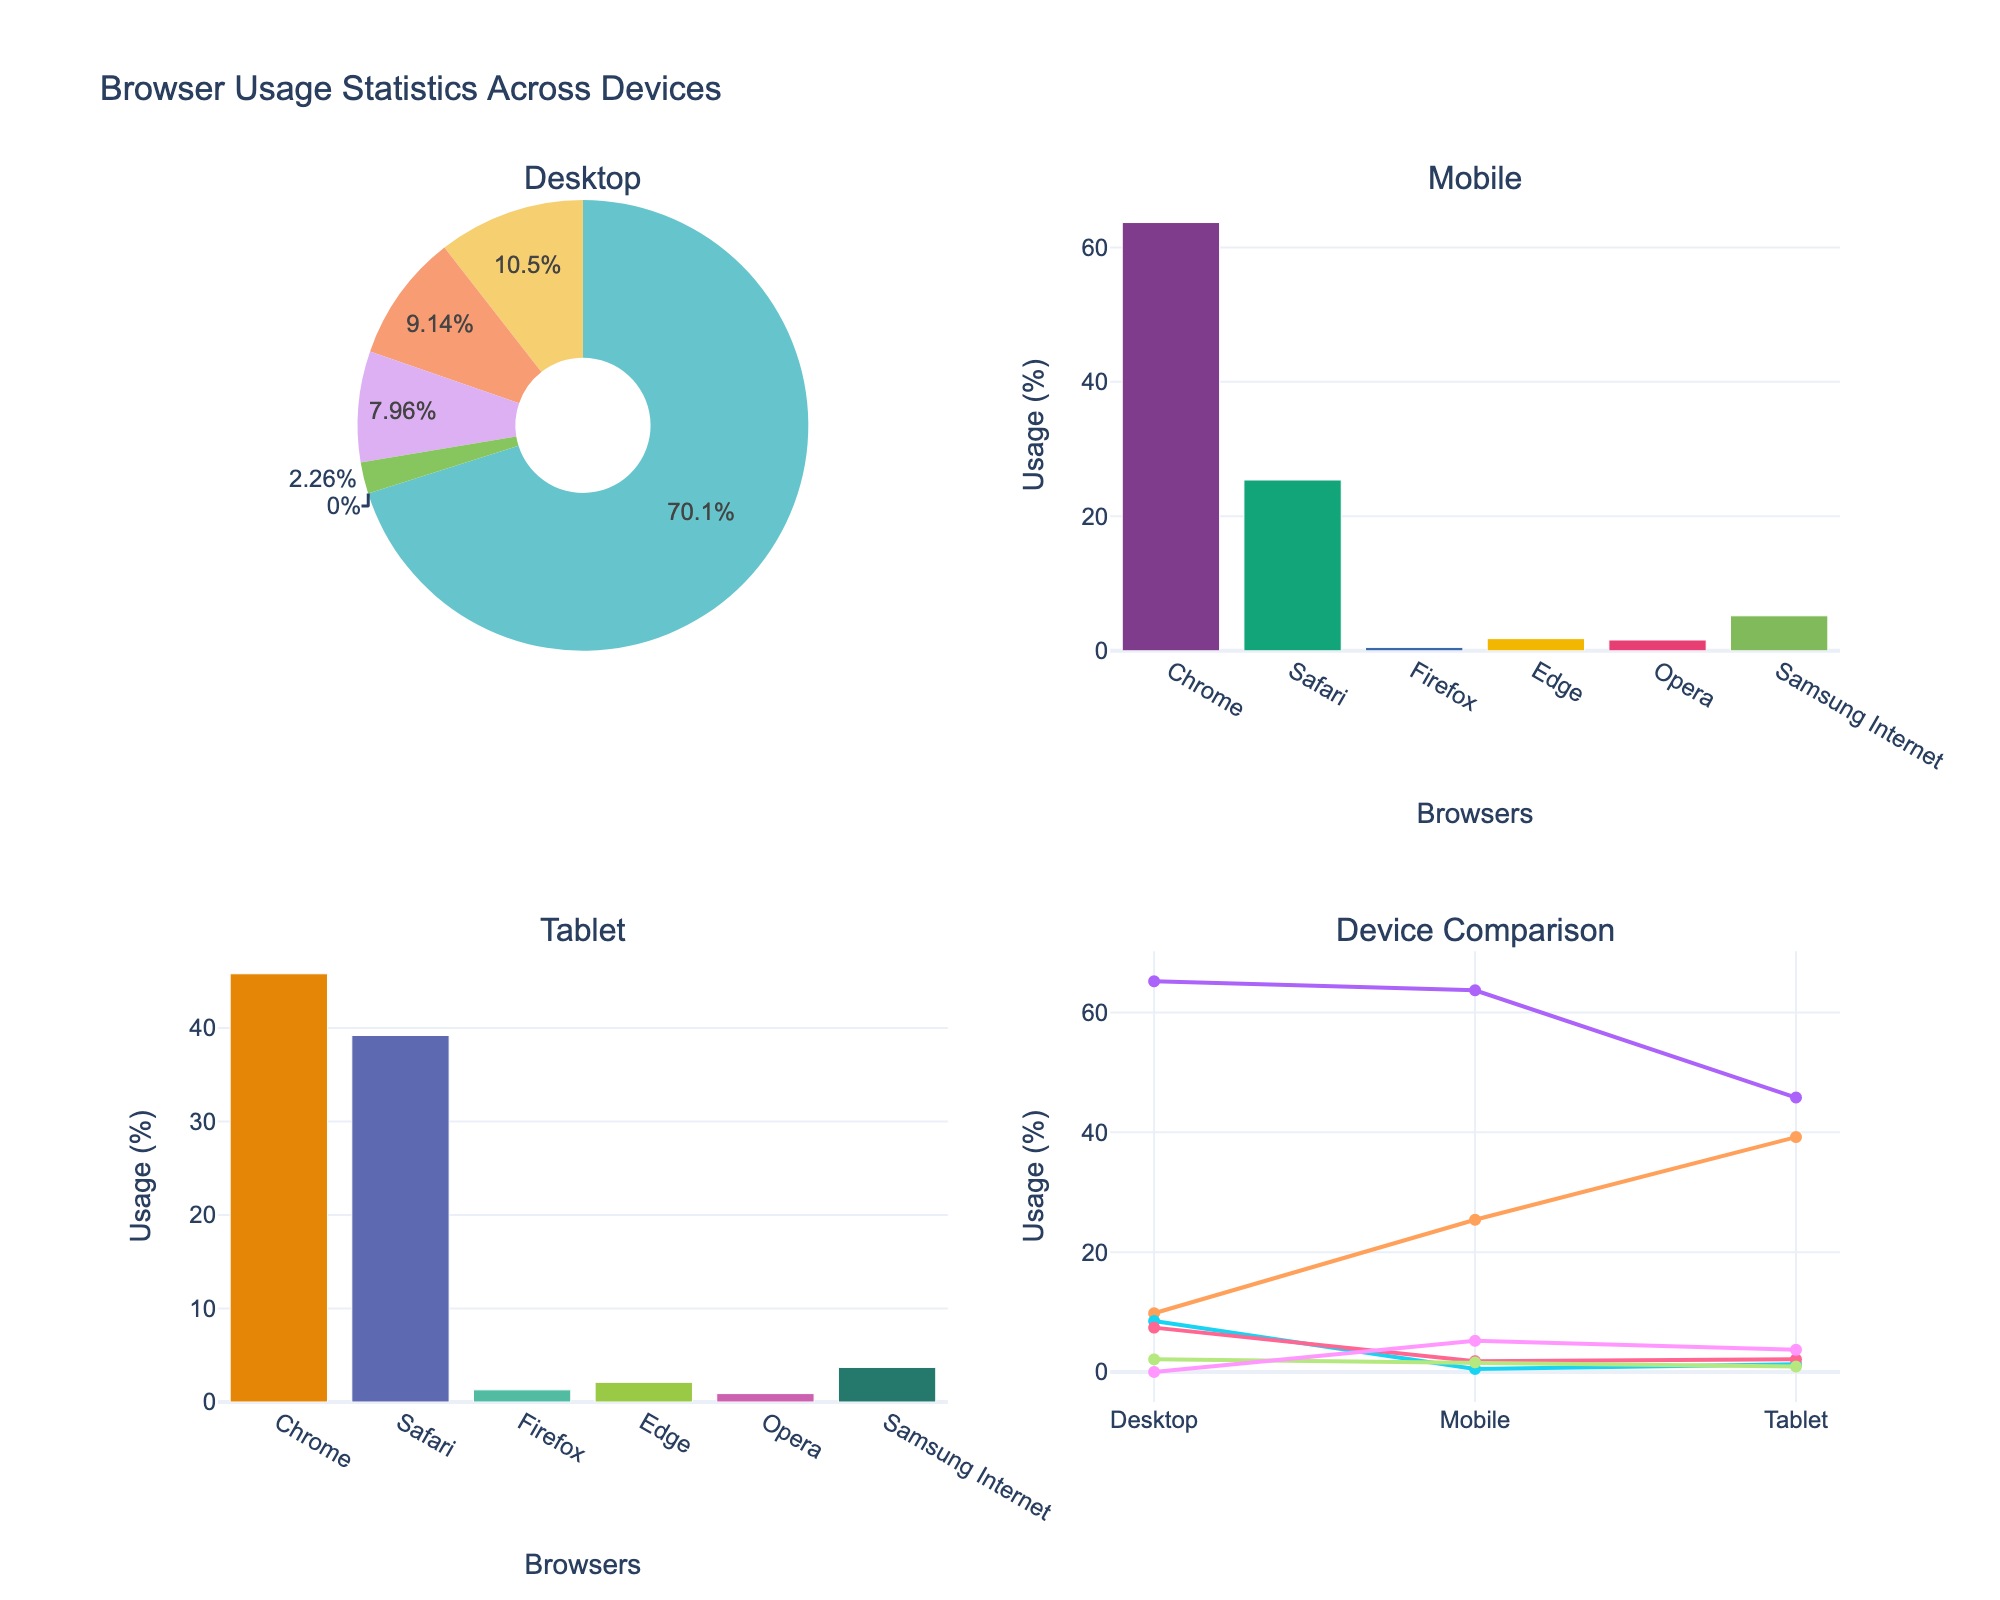What is the most used browser on desktops? By examining the desktop pie chart, we can see that the largest segment represents Chrome with a value of 65.2%. Therefore, Chrome is the most used browser on desktops.
Answer: Chrome Which device has the highest usage percentage for Safari? The bar charts for both Mobile and Tablet show Safari's usage percentages. For Mobile, it is 25.4%, while for Tablet, it is 39.2%. Comparing these, Tablet has the highest usage percentage for Safari.
Answer: Tablet How do the usage percentages of Firefox on desktops and mobiles compare? The desktop pie chart shows Firefox usage at 8.5%, and the mobile bar chart shows it at 0.5%. By comparing these values, Firefox usage is significantly higher on desktops than on mobiles.
Answer: Desktop What is the total browser usage percentage on tablets for browsers other than Samsung Internet? The tablet bar chart shows usage percentages for each browser: Chrome (45.8%), Safari (39.2%), Firefox (1.3%), Edge (2.1%), and Opera (0.9%). Summing these up gives: 45.8 + 39.2 + 1.3 + 2.1 + 0.9 = 89.3%.
Answer: 89.3% Which browser has consistent usage across all devices? By examining both bar charts and the pie chart for each device, we notice that Chrome has usage values of 65.2% (Desktop), 63.7% (Mobile), and 45.8% (Tablet). These values show a consistent high usage across all devices.
Answer: Chrome What percentage of tablet browser usage do Edge and Opera account for together? From the tablet bar chart, Edge has 2.1% and Opera has 0.9%. Adding them together, 2.1 + 0.9 = 3.0%.
Answer: 3.0% Which browser has the lowest usage on mobiles? The mobile bar chart shows that Firefox has the lowest usage on mobiles at 0.5%.
Answer: Firefox What is the average usage percentage of Chrome across all devices? On desktops, Chrome has 65.2%, on mobiles 63.7%, and on tablets 45.8%. Calculating the average: (65.2 + 63.7 + 45.8) / 3 = 58.23%.
Answer: 58.23% Of the three devices, on which is the sum of Safari and Samsung Internet usage the greatest? Examining the bar charts and pie chart for each device, the sums of Safari and Samsung Internet usage are: Desktop (9.8 + 0 = 9.8%), Mobile (25.4 + 5.2 = 30.6%), Tablet (39.2 + 3.7 = 42.9%). The greatest sum is on Tablets with 42.9%.
Answer: Tablet 